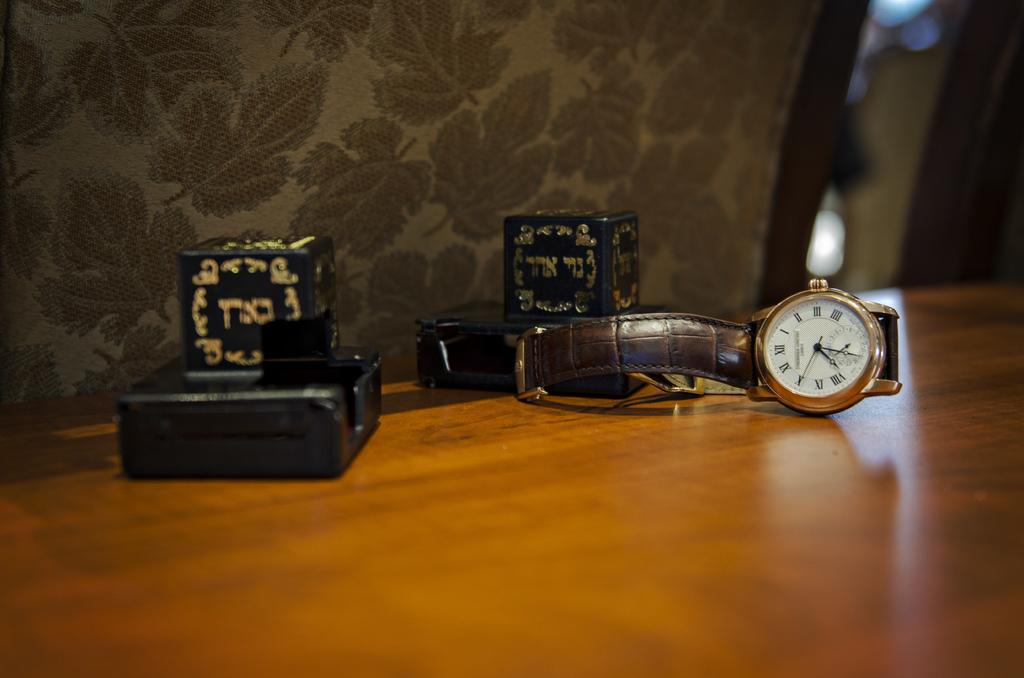<image>
Give a short and clear explanation of the subsequent image. Watch on a table with the hands on number 12 and 1. 